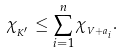Convert formula to latex. <formula><loc_0><loc_0><loc_500><loc_500>\chi _ { _ { K ^ { \prime } } } \leq \sum _ { i = 1 } ^ { n } \chi _ { _ { V + a _ { i } } } .</formula> 